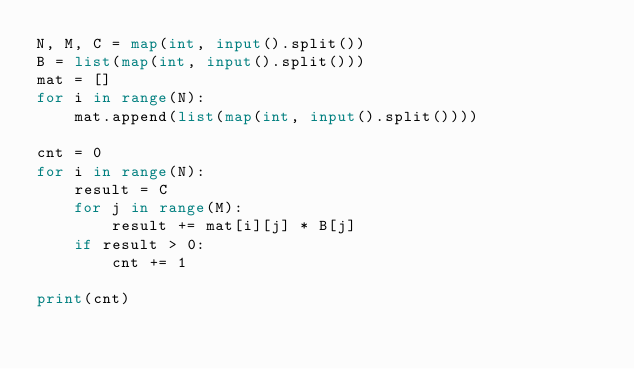<code> <loc_0><loc_0><loc_500><loc_500><_Python_>N, M, C = map(int, input().split())
B = list(map(int, input().split()))
mat = []
for i in range(N):
    mat.append(list(map(int, input().split())))

cnt = 0
for i in range(N):
    result = C
    for j in range(M):
        result += mat[i][j] * B[j]
    if result > 0:
        cnt += 1

print(cnt)
</code> 